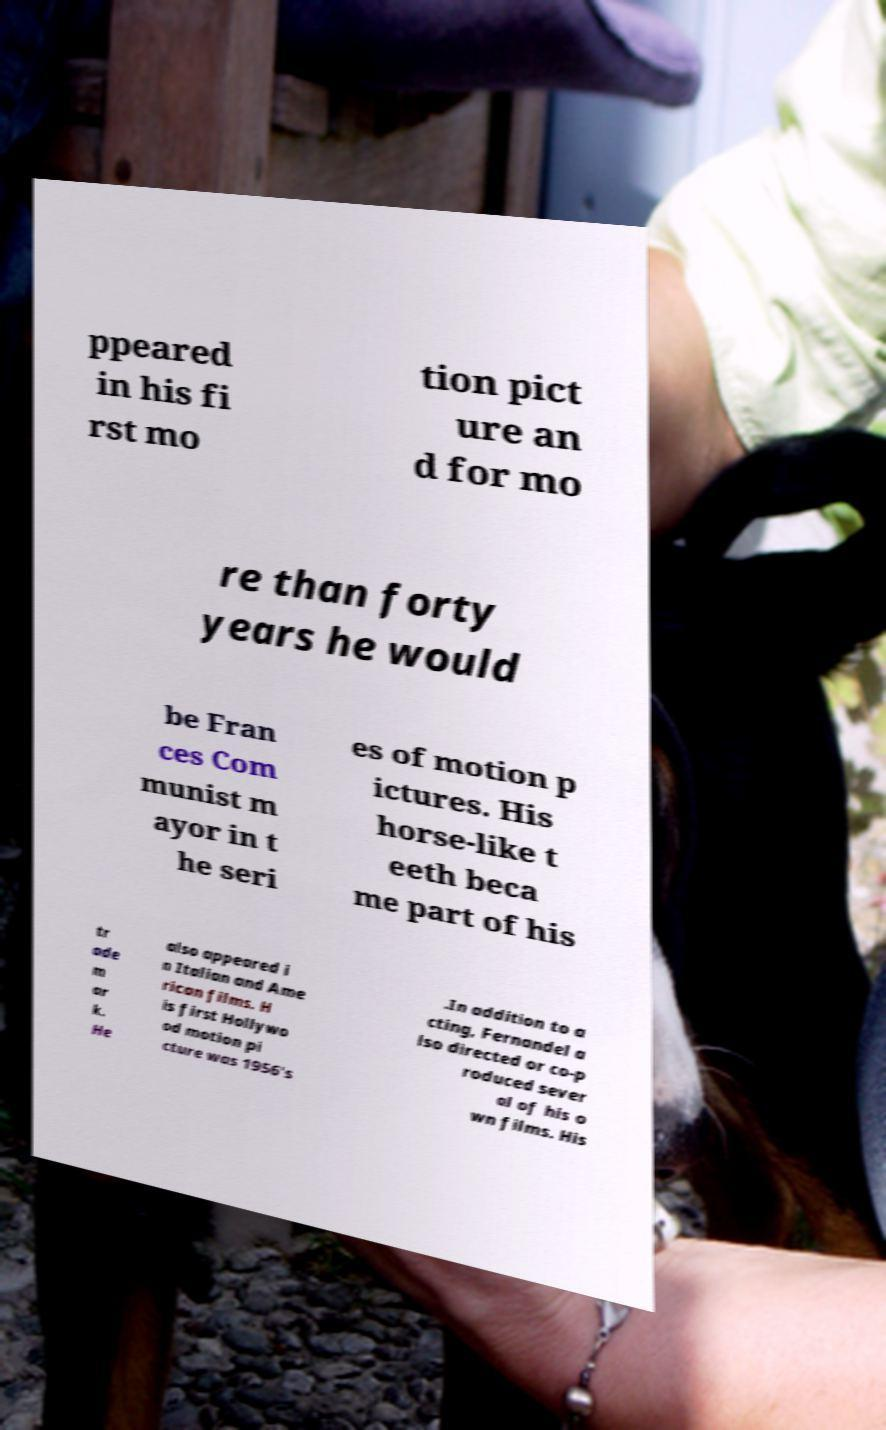Can you read and provide the text displayed in the image?This photo seems to have some interesting text. Can you extract and type it out for me? ppeared in his fi rst mo tion pict ure an d for mo re than forty years he would be Fran ces Com munist m ayor in t he seri es of motion p ictures. His horse-like t eeth beca me part of his tr ade m ar k. He also appeared i n Italian and Ame rican films. H is first Hollywo od motion pi cture was 1956's .In addition to a cting, Fernandel a lso directed or co-p roduced sever al of his o wn films. His 